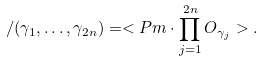<formula> <loc_0><loc_0><loc_500><loc_500>\ \slash ( \gamma _ { 1 } , \dots , \gamma _ { 2 n } ) = < P m \cdot \prod _ { j = 1 } ^ { 2 n } O _ { \gamma _ { j } } > .</formula> 